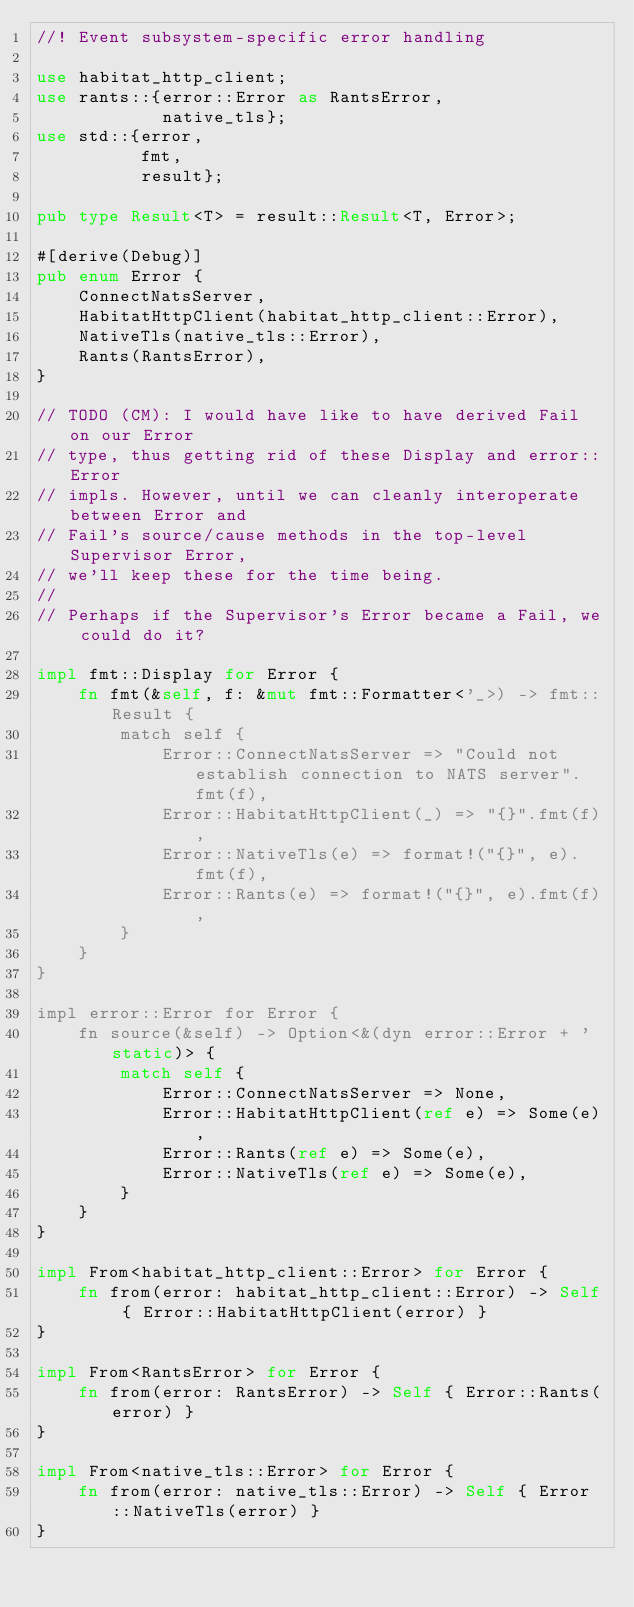Convert code to text. <code><loc_0><loc_0><loc_500><loc_500><_Rust_>//! Event subsystem-specific error handling

use habitat_http_client;
use rants::{error::Error as RantsError,
            native_tls};
use std::{error,
          fmt,
          result};

pub type Result<T> = result::Result<T, Error>;

#[derive(Debug)]
pub enum Error {
    ConnectNatsServer,
    HabitatHttpClient(habitat_http_client::Error),
    NativeTls(native_tls::Error),
    Rants(RantsError),
}

// TODO (CM): I would have like to have derived Fail on our Error
// type, thus getting rid of these Display and error::Error
// impls. However, until we can cleanly interoperate between Error and
// Fail's source/cause methods in the top-level Supervisor Error,
// we'll keep these for the time being.
//
// Perhaps if the Supervisor's Error became a Fail, we could do it?

impl fmt::Display for Error {
    fn fmt(&self, f: &mut fmt::Formatter<'_>) -> fmt::Result {
        match self {
            Error::ConnectNatsServer => "Could not establish connection to NATS server".fmt(f),
            Error::HabitatHttpClient(_) => "{}".fmt(f),
            Error::NativeTls(e) => format!("{}", e).fmt(f),
            Error::Rants(e) => format!("{}", e).fmt(f),
        }
    }
}

impl error::Error for Error {
    fn source(&self) -> Option<&(dyn error::Error + 'static)> {
        match self {
            Error::ConnectNatsServer => None,
            Error::HabitatHttpClient(ref e) => Some(e),
            Error::Rants(ref e) => Some(e),
            Error::NativeTls(ref e) => Some(e),
        }
    }
}

impl From<habitat_http_client::Error> for Error {
    fn from(error: habitat_http_client::Error) -> Self { Error::HabitatHttpClient(error) }
}

impl From<RantsError> for Error {
    fn from(error: RantsError) -> Self { Error::Rants(error) }
}

impl From<native_tls::Error> for Error {
    fn from(error: native_tls::Error) -> Self { Error::NativeTls(error) }
}
</code> 